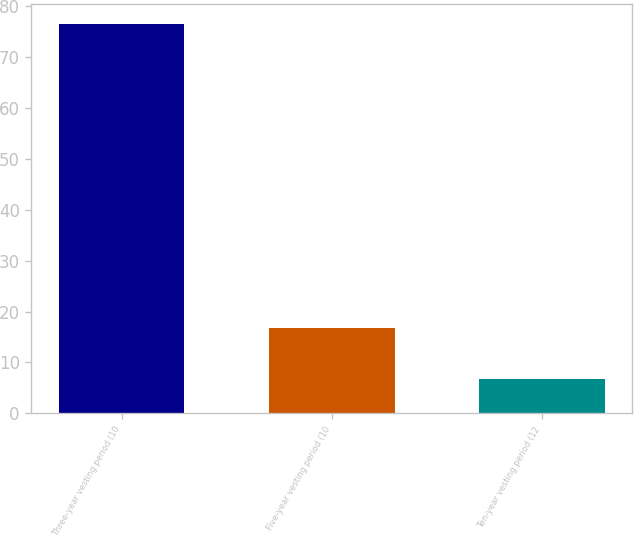<chart> <loc_0><loc_0><loc_500><loc_500><bar_chart><fcel>Three-year vesting period (10<fcel>Five-year vesting period (10<fcel>Ten-year vesting period (12<nl><fcel>76.6<fcel>16.7<fcel>6.7<nl></chart> 